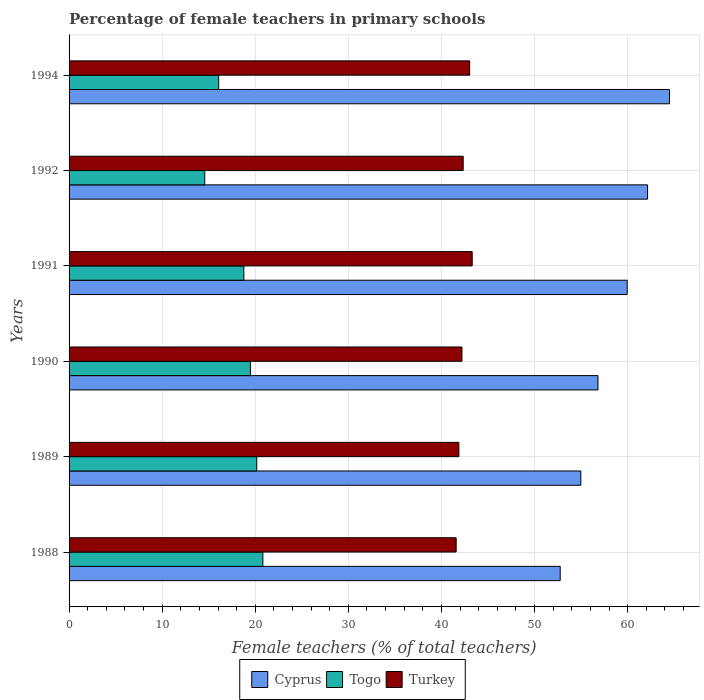How many different coloured bars are there?
Your answer should be compact. 3. How many groups of bars are there?
Make the answer very short. 6. Are the number of bars on each tick of the Y-axis equal?
Offer a terse response. Yes. What is the label of the 5th group of bars from the top?
Your answer should be very brief. 1989. What is the percentage of female teachers in Turkey in 1991?
Offer a terse response. 43.3. Across all years, what is the maximum percentage of female teachers in Togo?
Ensure brevity in your answer.  20.82. Across all years, what is the minimum percentage of female teachers in Turkey?
Provide a short and direct response. 41.58. In which year was the percentage of female teachers in Cyprus minimum?
Your answer should be compact. 1988. What is the total percentage of female teachers in Togo in the graph?
Offer a terse response. 109.88. What is the difference between the percentage of female teachers in Togo in 1991 and that in 1992?
Provide a succinct answer. 4.2. What is the difference between the percentage of female teachers in Cyprus in 1990 and the percentage of female teachers in Turkey in 1992?
Offer a very short reply. 14.48. What is the average percentage of female teachers in Turkey per year?
Offer a terse response. 42.39. In the year 1990, what is the difference between the percentage of female teachers in Togo and percentage of female teachers in Cyprus?
Provide a short and direct response. -37.34. What is the ratio of the percentage of female teachers in Cyprus in 1988 to that in 1992?
Your answer should be very brief. 0.85. What is the difference between the highest and the second highest percentage of female teachers in Turkey?
Your answer should be compact. 0.27. What is the difference between the highest and the lowest percentage of female teachers in Cyprus?
Make the answer very short. 11.74. In how many years, is the percentage of female teachers in Cyprus greater than the average percentage of female teachers in Cyprus taken over all years?
Offer a terse response. 3. Is the sum of the percentage of female teachers in Turkey in 1991 and 1992 greater than the maximum percentage of female teachers in Cyprus across all years?
Your answer should be very brief. Yes. What does the 2nd bar from the top in 1988 represents?
Give a very brief answer. Togo. What does the 1st bar from the bottom in 1994 represents?
Provide a succinct answer. Cyprus. Does the graph contain grids?
Ensure brevity in your answer.  Yes. Where does the legend appear in the graph?
Ensure brevity in your answer.  Bottom center. What is the title of the graph?
Provide a short and direct response. Percentage of female teachers in primary schools. What is the label or title of the X-axis?
Make the answer very short. Female teachers (% of total teachers). What is the label or title of the Y-axis?
Offer a terse response. Years. What is the Female teachers (% of total teachers) in Cyprus in 1988?
Provide a short and direct response. 52.76. What is the Female teachers (% of total teachers) of Togo in 1988?
Ensure brevity in your answer.  20.82. What is the Female teachers (% of total teachers) of Turkey in 1988?
Your answer should be very brief. 41.58. What is the Female teachers (% of total teachers) of Cyprus in 1989?
Provide a short and direct response. 54.98. What is the Female teachers (% of total teachers) in Togo in 1989?
Make the answer very short. 20.16. What is the Female teachers (% of total teachers) of Turkey in 1989?
Your answer should be compact. 41.87. What is the Female teachers (% of total teachers) in Cyprus in 1990?
Your answer should be very brief. 56.82. What is the Female teachers (% of total teachers) of Togo in 1990?
Keep it short and to the point. 19.48. What is the Female teachers (% of total teachers) in Turkey in 1990?
Provide a succinct answer. 42.2. What is the Female teachers (% of total teachers) of Cyprus in 1991?
Your answer should be very brief. 59.95. What is the Female teachers (% of total teachers) in Togo in 1991?
Provide a succinct answer. 18.78. What is the Female teachers (% of total teachers) of Turkey in 1991?
Give a very brief answer. 43.3. What is the Female teachers (% of total teachers) in Cyprus in 1992?
Give a very brief answer. 62.14. What is the Female teachers (% of total teachers) in Togo in 1992?
Your response must be concise. 14.57. What is the Female teachers (% of total teachers) of Turkey in 1992?
Offer a terse response. 42.34. What is the Female teachers (% of total teachers) of Cyprus in 1994?
Offer a very short reply. 64.5. What is the Female teachers (% of total teachers) of Togo in 1994?
Ensure brevity in your answer.  16.07. What is the Female teachers (% of total teachers) of Turkey in 1994?
Keep it short and to the point. 43.03. Across all years, what is the maximum Female teachers (% of total teachers) in Cyprus?
Provide a short and direct response. 64.5. Across all years, what is the maximum Female teachers (% of total teachers) in Togo?
Your response must be concise. 20.82. Across all years, what is the maximum Female teachers (% of total teachers) of Turkey?
Offer a very short reply. 43.3. Across all years, what is the minimum Female teachers (% of total teachers) of Cyprus?
Offer a very short reply. 52.76. Across all years, what is the minimum Female teachers (% of total teachers) of Togo?
Make the answer very short. 14.57. Across all years, what is the minimum Female teachers (% of total teachers) in Turkey?
Offer a terse response. 41.58. What is the total Female teachers (% of total teachers) of Cyprus in the graph?
Make the answer very short. 351.14. What is the total Female teachers (% of total teachers) in Togo in the graph?
Give a very brief answer. 109.88. What is the total Female teachers (% of total teachers) in Turkey in the graph?
Your answer should be compact. 254.33. What is the difference between the Female teachers (% of total teachers) of Cyprus in 1988 and that in 1989?
Keep it short and to the point. -2.22. What is the difference between the Female teachers (% of total teachers) of Togo in 1988 and that in 1989?
Offer a terse response. 0.66. What is the difference between the Female teachers (% of total teachers) of Turkey in 1988 and that in 1989?
Provide a short and direct response. -0.29. What is the difference between the Female teachers (% of total teachers) in Cyprus in 1988 and that in 1990?
Provide a short and direct response. -4.06. What is the difference between the Female teachers (% of total teachers) of Togo in 1988 and that in 1990?
Your response must be concise. 1.34. What is the difference between the Female teachers (% of total teachers) of Turkey in 1988 and that in 1990?
Your response must be concise. -0.62. What is the difference between the Female teachers (% of total teachers) in Cyprus in 1988 and that in 1991?
Make the answer very short. -7.2. What is the difference between the Female teachers (% of total teachers) of Togo in 1988 and that in 1991?
Your answer should be very brief. 2.04. What is the difference between the Female teachers (% of total teachers) in Turkey in 1988 and that in 1991?
Your answer should be compact. -1.72. What is the difference between the Female teachers (% of total teachers) in Cyprus in 1988 and that in 1992?
Your answer should be compact. -9.38. What is the difference between the Female teachers (% of total teachers) in Togo in 1988 and that in 1992?
Offer a very short reply. 6.24. What is the difference between the Female teachers (% of total teachers) in Turkey in 1988 and that in 1992?
Make the answer very short. -0.76. What is the difference between the Female teachers (% of total teachers) of Cyprus in 1988 and that in 1994?
Give a very brief answer. -11.74. What is the difference between the Female teachers (% of total teachers) of Togo in 1988 and that in 1994?
Your answer should be compact. 4.75. What is the difference between the Female teachers (% of total teachers) of Turkey in 1988 and that in 1994?
Make the answer very short. -1.45. What is the difference between the Female teachers (% of total teachers) in Cyprus in 1989 and that in 1990?
Your answer should be compact. -1.84. What is the difference between the Female teachers (% of total teachers) in Togo in 1989 and that in 1990?
Give a very brief answer. 0.68. What is the difference between the Female teachers (% of total teachers) in Turkey in 1989 and that in 1990?
Give a very brief answer. -0.33. What is the difference between the Female teachers (% of total teachers) in Cyprus in 1989 and that in 1991?
Provide a short and direct response. -4.98. What is the difference between the Female teachers (% of total teachers) of Togo in 1989 and that in 1991?
Offer a very short reply. 1.39. What is the difference between the Female teachers (% of total teachers) in Turkey in 1989 and that in 1991?
Offer a very short reply. -1.43. What is the difference between the Female teachers (% of total teachers) of Cyprus in 1989 and that in 1992?
Give a very brief answer. -7.17. What is the difference between the Female teachers (% of total teachers) of Togo in 1989 and that in 1992?
Your answer should be compact. 5.59. What is the difference between the Female teachers (% of total teachers) in Turkey in 1989 and that in 1992?
Your response must be concise. -0.46. What is the difference between the Female teachers (% of total teachers) of Cyprus in 1989 and that in 1994?
Offer a very short reply. -9.52. What is the difference between the Female teachers (% of total teachers) of Togo in 1989 and that in 1994?
Keep it short and to the point. 4.09. What is the difference between the Female teachers (% of total teachers) in Turkey in 1989 and that in 1994?
Ensure brevity in your answer.  -1.16. What is the difference between the Female teachers (% of total teachers) in Cyprus in 1990 and that in 1991?
Your answer should be compact. -3.14. What is the difference between the Female teachers (% of total teachers) of Togo in 1990 and that in 1991?
Provide a short and direct response. 0.71. What is the difference between the Female teachers (% of total teachers) of Turkey in 1990 and that in 1991?
Your response must be concise. -1.1. What is the difference between the Female teachers (% of total teachers) in Cyprus in 1990 and that in 1992?
Offer a very short reply. -5.33. What is the difference between the Female teachers (% of total teachers) of Togo in 1990 and that in 1992?
Give a very brief answer. 4.91. What is the difference between the Female teachers (% of total teachers) of Turkey in 1990 and that in 1992?
Make the answer very short. -0.13. What is the difference between the Female teachers (% of total teachers) in Cyprus in 1990 and that in 1994?
Keep it short and to the point. -7.68. What is the difference between the Female teachers (% of total teachers) of Togo in 1990 and that in 1994?
Your answer should be very brief. 3.41. What is the difference between the Female teachers (% of total teachers) in Turkey in 1990 and that in 1994?
Keep it short and to the point. -0.83. What is the difference between the Female teachers (% of total teachers) in Cyprus in 1991 and that in 1992?
Your answer should be very brief. -2.19. What is the difference between the Female teachers (% of total teachers) of Togo in 1991 and that in 1992?
Give a very brief answer. 4.2. What is the difference between the Female teachers (% of total teachers) of Turkey in 1991 and that in 1992?
Give a very brief answer. 0.97. What is the difference between the Female teachers (% of total teachers) in Cyprus in 1991 and that in 1994?
Your answer should be very brief. -4.54. What is the difference between the Female teachers (% of total teachers) in Togo in 1991 and that in 1994?
Offer a terse response. 2.7. What is the difference between the Female teachers (% of total teachers) in Turkey in 1991 and that in 1994?
Provide a short and direct response. 0.27. What is the difference between the Female teachers (% of total teachers) in Cyprus in 1992 and that in 1994?
Provide a succinct answer. -2.35. What is the difference between the Female teachers (% of total teachers) of Togo in 1992 and that in 1994?
Give a very brief answer. -1.5. What is the difference between the Female teachers (% of total teachers) of Turkey in 1992 and that in 1994?
Keep it short and to the point. -0.7. What is the difference between the Female teachers (% of total teachers) of Cyprus in 1988 and the Female teachers (% of total teachers) of Togo in 1989?
Ensure brevity in your answer.  32.6. What is the difference between the Female teachers (% of total teachers) in Cyprus in 1988 and the Female teachers (% of total teachers) in Turkey in 1989?
Give a very brief answer. 10.88. What is the difference between the Female teachers (% of total teachers) of Togo in 1988 and the Female teachers (% of total teachers) of Turkey in 1989?
Keep it short and to the point. -21.06. What is the difference between the Female teachers (% of total teachers) of Cyprus in 1988 and the Female teachers (% of total teachers) of Togo in 1990?
Keep it short and to the point. 33.28. What is the difference between the Female teachers (% of total teachers) in Cyprus in 1988 and the Female teachers (% of total teachers) in Turkey in 1990?
Your answer should be very brief. 10.55. What is the difference between the Female teachers (% of total teachers) of Togo in 1988 and the Female teachers (% of total teachers) of Turkey in 1990?
Your answer should be compact. -21.39. What is the difference between the Female teachers (% of total teachers) in Cyprus in 1988 and the Female teachers (% of total teachers) in Togo in 1991?
Offer a very short reply. 33.98. What is the difference between the Female teachers (% of total teachers) in Cyprus in 1988 and the Female teachers (% of total teachers) in Turkey in 1991?
Keep it short and to the point. 9.45. What is the difference between the Female teachers (% of total teachers) in Togo in 1988 and the Female teachers (% of total teachers) in Turkey in 1991?
Your answer should be compact. -22.49. What is the difference between the Female teachers (% of total teachers) in Cyprus in 1988 and the Female teachers (% of total teachers) in Togo in 1992?
Your answer should be compact. 38.18. What is the difference between the Female teachers (% of total teachers) in Cyprus in 1988 and the Female teachers (% of total teachers) in Turkey in 1992?
Keep it short and to the point. 10.42. What is the difference between the Female teachers (% of total teachers) of Togo in 1988 and the Female teachers (% of total teachers) of Turkey in 1992?
Offer a terse response. -21.52. What is the difference between the Female teachers (% of total teachers) in Cyprus in 1988 and the Female teachers (% of total teachers) in Togo in 1994?
Offer a very short reply. 36.69. What is the difference between the Female teachers (% of total teachers) of Cyprus in 1988 and the Female teachers (% of total teachers) of Turkey in 1994?
Your answer should be compact. 9.73. What is the difference between the Female teachers (% of total teachers) of Togo in 1988 and the Female teachers (% of total teachers) of Turkey in 1994?
Give a very brief answer. -22.21. What is the difference between the Female teachers (% of total teachers) in Cyprus in 1989 and the Female teachers (% of total teachers) in Togo in 1990?
Provide a succinct answer. 35.5. What is the difference between the Female teachers (% of total teachers) in Cyprus in 1989 and the Female teachers (% of total teachers) in Turkey in 1990?
Offer a very short reply. 12.77. What is the difference between the Female teachers (% of total teachers) in Togo in 1989 and the Female teachers (% of total teachers) in Turkey in 1990?
Give a very brief answer. -22.04. What is the difference between the Female teachers (% of total teachers) in Cyprus in 1989 and the Female teachers (% of total teachers) in Togo in 1991?
Provide a succinct answer. 36.2. What is the difference between the Female teachers (% of total teachers) in Cyprus in 1989 and the Female teachers (% of total teachers) in Turkey in 1991?
Your answer should be compact. 11.67. What is the difference between the Female teachers (% of total teachers) of Togo in 1989 and the Female teachers (% of total teachers) of Turkey in 1991?
Provide a short and direct response. -23.14. What is the difference between the Female teachers (% of total teachers) in Cyprus in 1989 and the Female teachers (% of total teachers) in Togo in 1992?
Offer a terse response. 40.4. What is the difference between the Female teachers (% of total teachers) in Cyprus in 1989 and the Female teachers (% of total teachers) in Turkey in 1992?
Keep it short and to the point. 12.64. What is the difference between the Female teachers (% of total teachers) in Togo in 1989 and the Female teachers (% of total teachers) in Turkey in 1992?
Ensure brevity in your answer.  -22.18. What is the difference between the Female teachers (% of total teachers) in Cyprus in 1989 and the Female teachers (% of total teachers) in Togo in 1994?
Offer a terse response. 38.9. What is the difference between the Female teachers (% of total teachers) of Cyprus in 1989 and the Female teachers (% of total teachers) of Turkey in 1994?
Offer a terse response. 11.94. What is the difference between the Female teachers (% of total teachers) of Togo in 1989 and the Female teachers (% of total teachers) of Turkey in 1994?
Keep it short and to the point. -22.87. What is the difference between the Female teachers (% of total teachers) of Cyprus in 1990 and the Female teachers (% of total teachers) of Togo in 1991?
Provide a short and direct response. 38.04. What is the difference between the Female teachers (% of total teachers) of Cyprus in 1990 and the Female teachers (% of total teachers) of Turkey in 1991?
Provide a short and direct response. 13.51. What is the difference between the Female teachers (% of total teachers) in Togo in 1990 and the Female teachers (% of total teachers) in Turkey in 1991?
Your answer should be very brief. -23.82. What is the difference between the Female teachers (% of total teachers) of Cyprus in 1990 and the Female teachers (% of total teachers) of Togo in 1992?
Make the answer very short. 42.24. What is the difference between the Female teachers (% of total teachers) of Cyprus in 1990 and the Female teachers (% of total teachers) of Turkey in 1992?
Offer a terse response. 14.48. What is the difference between the Female teachers (% of total teachers) of Togo in 1990 and the Female teachers (% of total teachers) of Turkey in 1992?
Your response must be concise. -22.86. What is the difference between the Female teachers (% of total teachers) of Cyprus in 1990 and the Female teachers (% of total teachers) of Togo in 1994?
Your answer should be compact. 40.74. What is the difference between the Female teachers (% of total teachers) of Cyprus in 1990 and the Female teachers (% of total teachers) of Turkey in 1994?
Your answer should be compact. 13.78. What is the difference between the Female teachers (% of total teachers) of Togo in 1990 and the Female teachers (% of total teachers) of Turkey in 1994?
Offer a terse response. -23.55. What is the difference between the Female teachers (% of total teachers) in Cyprus in 1991 and the Female teachers (% of total teachers) in Togo in 1992?
Ensure brevity in your answer.  45.38. What is the difference between the Female teachers (% of total teachers) in Cyprus in 1991 and the Female teachers (% of total teachers) in Turkey in 1992?
Your response must be concise. 17.62. What is the difference between the Female teachers (% of total teachers) of Togo in 1991 and the Female teachers (% of total teachers) of Turkey in 1992?
Your answer should be compact. -23.56. What is the difference between the Female teachers (% of total teachers) in Cyprus in 1991 and the Female teachers (% of total teachers) in Togo in 1994?
Ensure brevity in your answer.  43.88. What is the difference between the Female teachers (% of total teachers) in Cyprus in 1991 and the Female teachers (% of total teachers) in Turkey in 1994?
Your answer should be compact. 16.92. What is the difference between the Female teachers (% of total teachers) of Togo in 1991 and the Female teachers (% of total teachers) of Turkey in 1994?
Make the answer very short. -24.26. What is the difference between the Female teachers (% of total teachers) of Cyprus in 1992 and the Female teachers (% of total teachers) of Togo in 1994?
Your response must be concise. 46.07. What is the difference between the Female teachers (% of total teachers) in Cyprus in 1992 and the Female teachers (% of total teachers) in Turkey in 1994?
Ensure brevity in your answer.  19.11. What is the difference between the Female teachers (% of total teachers) in Togo in 1992 and the Female teachers (% of total teachers) in Turkey in 1994?
Your answer should be compact. -28.46. What is the average Female teachers (% of total teachers) in Cyprus per year?
Your response must be concise. 58.52. What is the average Female teachers (% of total teachers) of Togo per year?
Your answer should be very brief. 18.31. What is the average Female teachers (% of total teachers) in Turkey per year?
Ensure brevity in your answer.  42.39. In the year 1988, what is the difference between the Female teachers (% of total teachers) in Cyprus and Female teachers (% of total teachers) in Togo?
Provide a succinct answer. 31.94. In the year 1988, what is the difference between the Female teachers (% of total teachers) in Cyprus and Female teachers (% of total teachers) in Turkey?
Provide a short and direct response. 11.18. In the year 1988, what is the difference between the Female teachers (% of total teachers) in Togo and Female teachers (% of total teachers) in Turkey?
Ensure brevity in your answer.  -20.76. In the year 1989, what is the difference between the Female teachers (% of total teachers) in Cyprus and Female teachers (% of total teachers) in Togo?
Offer a terse response. 34.81. In the year 1989, what is the difference between the Female teachers (% of total teachers) in Cyprus and Female teachers (% of total teachers) in Turkey?
Offer a terse response. 13.1. In the year 1989, what is the difference between the Female teachers (% of total teachers) of Togo and Female teachers (% of total teachers) of Turkey?
Provide a succinct answer. -21.71. In the year 1990, what is the difference between the Female teachers (% of total teachers) of Cyprus and Female teachers (% of total teachers) of Togo?
Offer a terse response. 37.34. In the year 1990, what is the difference between the Female teachers (% of total teachers) of Cyprus and Female teachers (% of total teachers) of Turkey?
Your answer should be compact. 14.61. In the year 1990, what is the difference between the Female teachers (% of total teachers) of Togo and Female teachers (% of total teachers) of Turkey?
Offer a terse response. -22.72. In the year 1991, what is the difference between the Female teachers (% of total teachers) of Cyprus and Female teachers (% of total teachers) of Togo?
Your response must be concise. 41.18. In the year 1991, what is the difference between the Female teachers (% of total teachers) in Cyprus and Female teachers (% of total teachers) in Turkey?
Offer a terse response. 16.65. In the year 1991, what is the difference between the Female teachers (% of total teachers) of Togo and Female teachers (% of total teachers) of Turkey?
Provide a short and direct response. -24.53. In the year 1992, what is the difference between the Female teachers (% of total teachers) in Cyprus and Female teachers (% of total teachers) in Togo?
Offer a terse response. 47.57. In the year 1992, what is the difference between the Female teachers (% of total teachers) of Cyprus and Female teachers (% of total teachers) of Turkey?
Provide a short and direct response. 19.81. In the year 1992, what is the difference between the Female teachers (% of total teachers) of Togo and Female teachers (% of total teachers) of Turkey?
Offer a terse response. -27.76. In the year 1994, what is the difference between the Female teachers (% of total teachers) of Cyprus and Female teachers (% of total teachers) of Togo?
Your answer should be very brief. 48.42. In the year 1994, what is the difference between the Female teachers (% of total teachers) of Cyprus and Female teachers (% of total teachers) of Turkey?
Offer a very short reply. 21.46. In the year 1994, what is the difference between the Female teachers (% of total teachers) in Togo and Female teachers (% of total teachers) in Turkey?
Provide a short and direct response. -26.96. What is the ratio of the Female teachers (% of total teachers) of Cyprus in 1988 to that in 1989?
Provide a succinct answer. 0.96. What is the ratio of the Female teachers (% of total teachers) of Togo in 1988 to that in 1989?
Your answer should be compact. 1.03. What is the ratio of the Female teachers (% of total teachers) in Turkey in 1988 to that in 1989?
Ensure brevity in your answer.  0.99. What is the ratio of the Female teachers (% of total teachers) in Togo in 1988 to that in 1990?
Your response must be concise. 1.07. What is the ratio of the Female teachers (% of total teachers) of Turkey in 1988 to that in 1990?
Provide a short and direct response. 0.99. What is the ratio of the Female teachers (% of total teachers) of Togo in 1988 to that in 1991?
Your answer should be very brief. 1.11. What is the ratio of the Female teachers (% of total teachers) of Turkey in 1988 to that in 1991?
Ensure brevity in your answer.  0.96. What is the ratio of the Female teachers (% of total teachers) in Cyprus in 1988 to that in 1992?
Provide a succinct answer. 0.85. What is the ratio of the Female teachers (% of total teachers) in Togo in 1988 to that in 1992?
Ensure brevity in your answer.  1.43. What is the ratio of the Female teachers (% of total teachers) of Turkey in 1988 to that in 1992?
Your answer should be compact. 0.98. What is the ratio of the Female teachers (% of total teachers) in Cyprus in 1988 to that in 1994?
Ensure brevity in your answer.  0.82. What is the ratio of the Female teachers (% of total teachers) in Togo in 1988 to that in 1994?
Provide a succinct answer. 1.3. What is the ratio of the Female teachers (% of total teachers) of Turkey in 1988 to that in 1994?
Keep it short and to the point. 0.97. What is the ratio of the Female teachers (% of total teachers) of Cyprus in 1989 to that in 1990?
Offer a very short reply. 0.97. What is the ratio of the Female teachers (% of total teachers) in Togo in 1989 to that in 1990?
Give a very brief answer. 1.03. What is the ratio of the Female teachers (% of total teachers) in Turkey in 1989 to that in 1990?
Keep it short and to the point. 0.99. What is the ratio of the Female teachers (% of total teachers) in Cyprus in 1989 to that in 1991?
Give a very brief answer. 0.92. What is the ratio of the Female teachers (% of total teachers) in Togo in 1989 to that in 1991?
Offer a terse response. 1.07. What is the ratio of the Female teachers (% of total teachers) of Turkey in 1989 to that in 1991?
Your answer should be very brief. 0.97. What is the ratio of the Female teachers (% of total teachers) in Cyprus in 1989 to that in 1992?
Offer a terse response. 0.88. What is the ratio of the Female teachers (% of total teachers) in Togo in 1989 to that in 1992?
Provide a short and direct response. 1.38. What is the ratio of the Female teachers (% of total teachers) of Turkey in 1989 to that in 1992?
Provide a succinct answer. 0.99. What is the ratio of the Female teachers (% of total teachers) of Cyprus in 1989 to that in 1994?
Make the answer very short. 0.85. What is the ratio of the Female teachers (% of total teachers) of Togo in 1989 to that in 1994?
Keep it short and to the point. 1.25. What is the ratio of the Female teachers (% of total teachers) of Turkey in 1989 to that in 1994?
Provide a succinct answer. 0.97. What is the ratio of the Female teachers (% of total teachers) of Cyprus in 1990 to that in 1991?
Give a very brief answer. 0.95. What is the ratio of the Female teachers (% of total teachers) of Togo in 1990 to that in 1991?
Your answer should be very brief. 1.04. What is the ratio of the Female teachers (% of total teachers) of Turkey in 1990 to that in 1991?
Your answer should be very brief. 0.97. What is the ratio of the Female teachers (% of total teachers) of Cyprus in 1990 to that in 1992?
Make the answer very short. 0.91. What is the ratio of the Female teachers (% of total teachers) in Togo in 1990 to that in 1992?
Ensure brevity in your answer.  1.34. What is the ratio of the Female teachers (% of total teachers) in Turkey in 1990 to that in 1992?
Provide a succinct answer. 1. What is the ratio of the Female teachers (% of total teachers) of Cyprus in 1990 to that in 1994?
Provide a short and direct response. 0.88. What is the ratio of the Female teachers (% of total teachers) in Togo in 1990 to that in 1994?
Make the answer very short. 1.21. What is the ratio of the Female teachers (% of total teachers) of Turkey in 1990 to that in 1994?
Your answer should be compact. 0.98. What is the ratio of the Female teachers (% of total teachers) of Cyprus in 1991 to that in 1992?
Make the answer very short. 0.96. What is the ratio of the Female teachers (% of total teachers) in Togo in 1991 to that in 1992?
Your answer should be compact. 1.29. What is the ratio of the Female teachers (% of total teachers) of Turkey in 1991 to that in 1992?
Offer a very short reply. 1.02. What is the ratio of the Female teachers (% of total teachers) of Cyprus in 1991 to that in 1994?
Your response must be concise. 0.93. What is the ratio of the Female teachers (% of total teachers) of Togo in 1991 to that in 1994?
Make the answer very short. 1.17. What is the ratio of the Female teachers (% of total teachers) in Turkey in 1991 to that in 1994?
Your response must be concise. 1.01. What is the ratio of the Female teachers (% of total teachers) of Cyprus in 1992 to that in 1994?
Give a very brief answer. 0.96. What is the ratio of the Female teachers (% of total teachers) of Togo in 1992 to that in 1994?
Your answer should be compact. 0.91. What is the ratio of the Female teachers (% of total teachers) in Turkey in 1992 to that in 1994?
Your answer should be compact. 0.98. What is the difference between the highest and the second highest Female teachers (% of total teachers) of Cyprus?
Offer a very short reply. 2.35. What is the difference between the highest and the second highest Female teachers (% of total teachers) in Togo?
Make the answer very short. 0.66. What is the difference between the highest and the second highest Female teachers (% of total teachers) of Turkey?
Ensure brevity in your answer.  0.27. What is the difference between the highest and the lowest Female teachers (% of total teachers) of Cyprus?
Your response must be concise. 11.74. What is the difference between the highest and the lowest Female teachers (% of total teachers) of Togo?
Ensure brevity in your answer.  6.24. What is the difference between the highest and the lowest Female teachers (% of total teachers) of Turkey?
Provide a short and direct response. 1.72. 